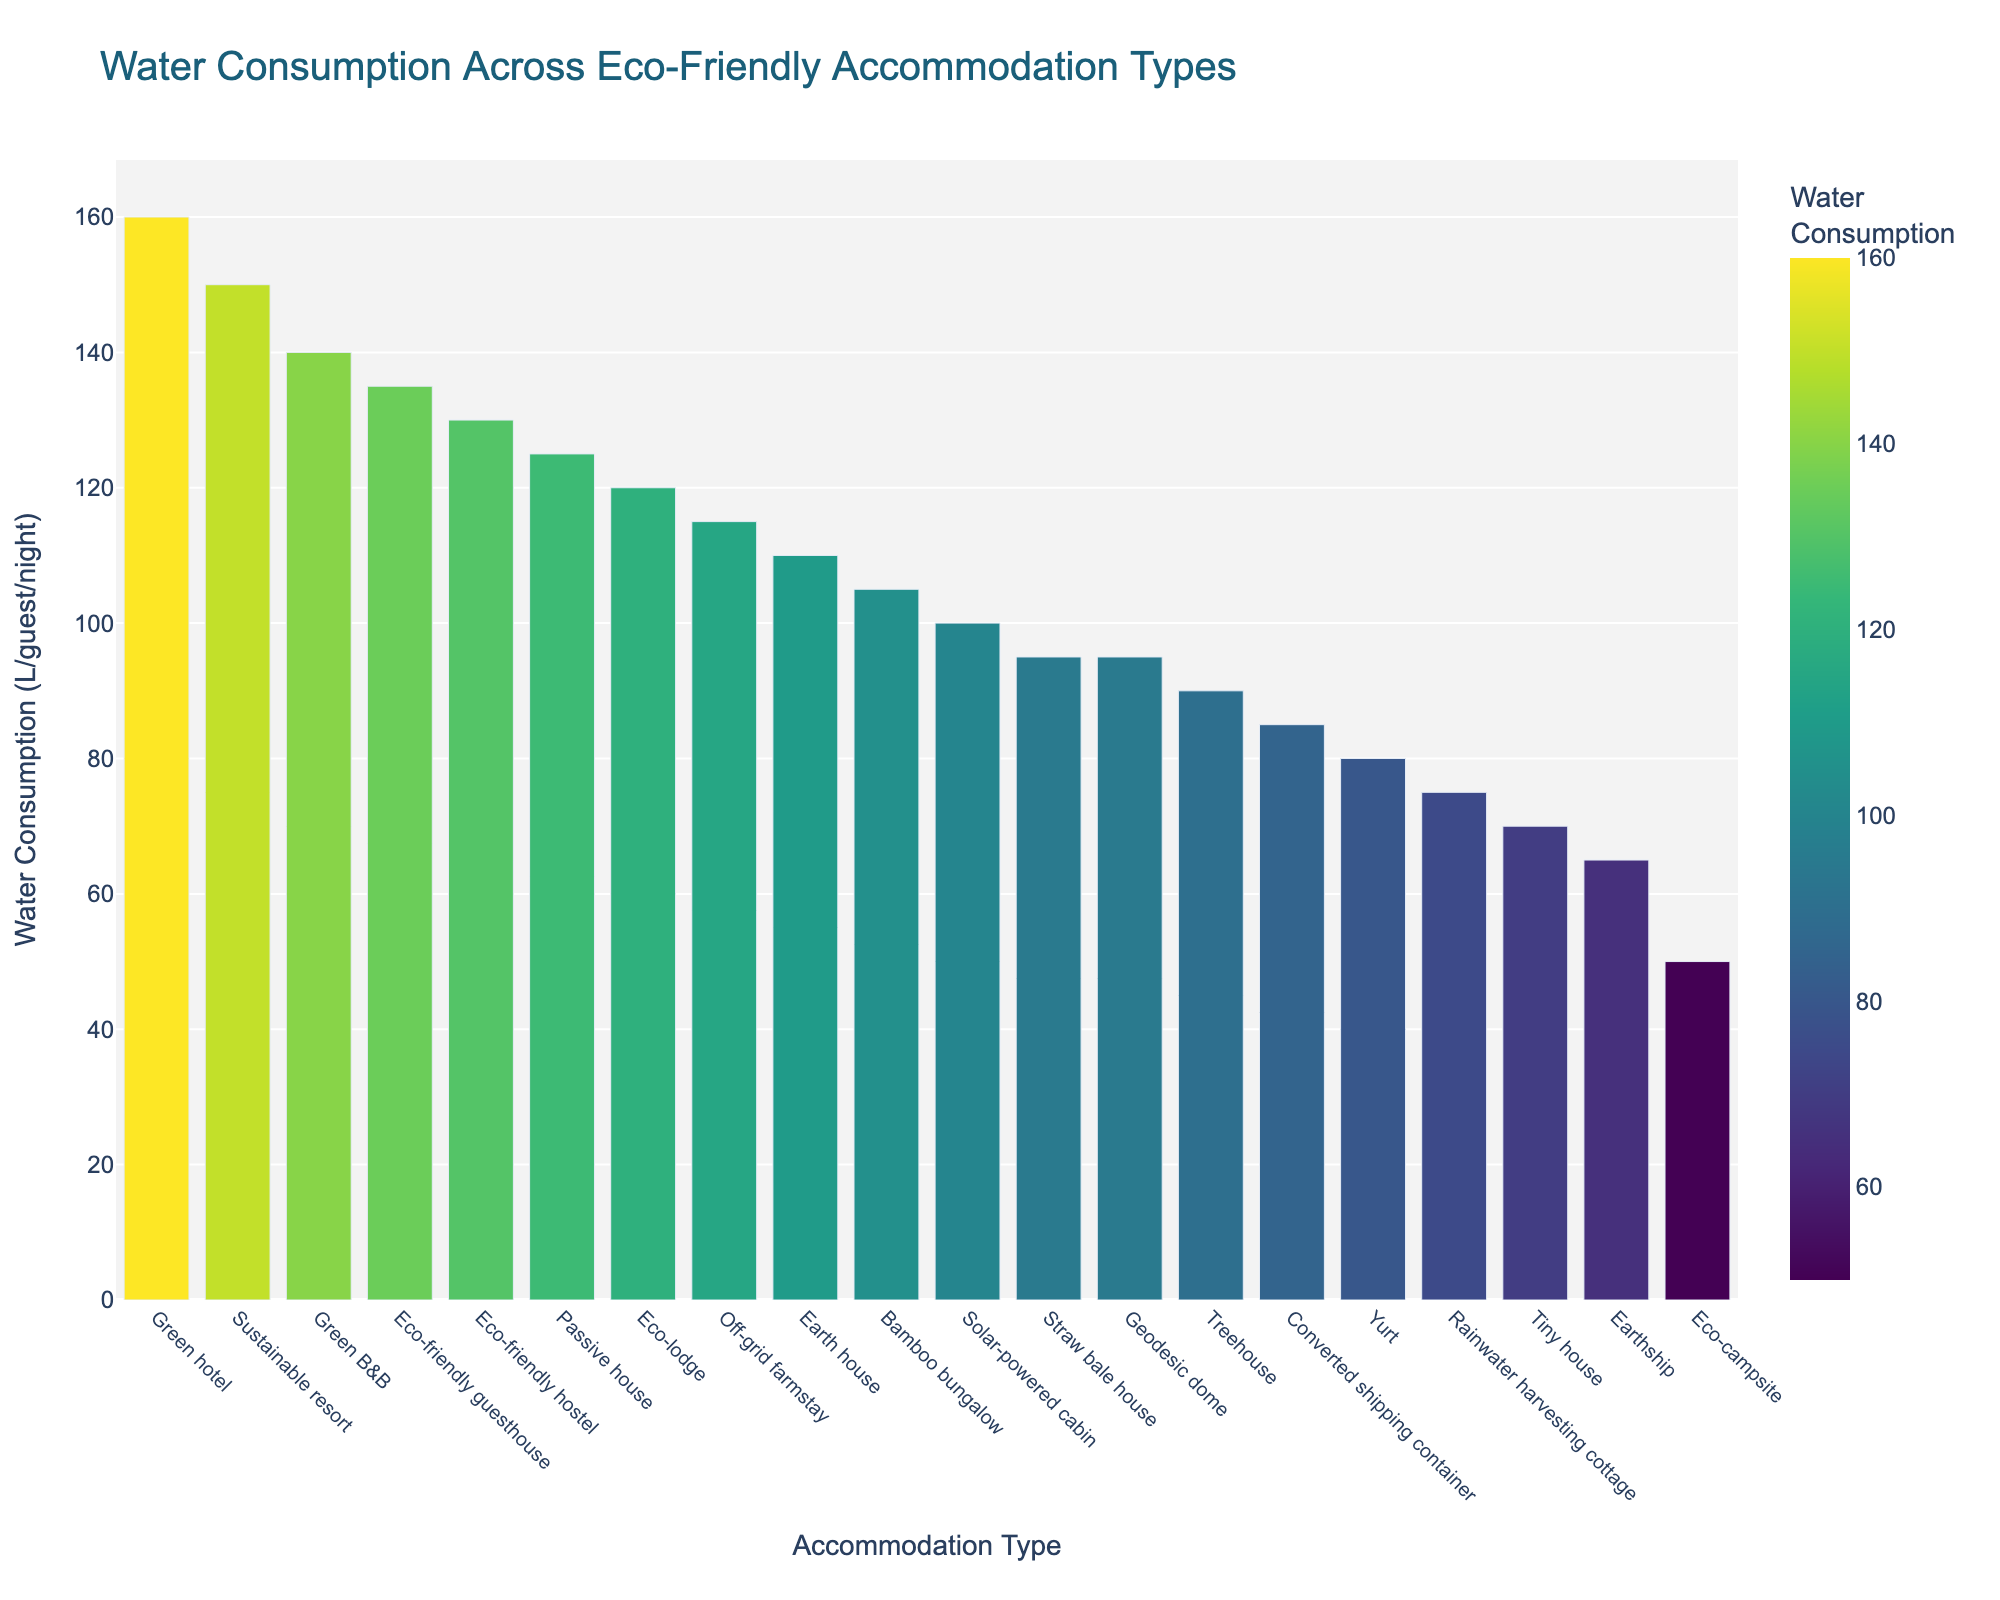Which accommodation type has the highest water consumption? Look at the bar chart and find the bar with the greatest height. The Green hotel has the highest value of 160 liters per guest per night.
Answer: Green hotel Which accommodation type has the lowest water consumption? Look at the bar chart and locate the bar with the smallest height. The Eco-campsite has the lowest value of 50 liters per guest per night.
Answer: Eco-campsite How much more water does a Green hotel consume compared to an Eco-lodge? Find the heights of the bars for the Green hotel and the Eco-lodge. The Green hotel consumes 160 liters, and the Eco-lodge consumes 120 liters, so the difference is 160 - 120.
Answer: 40 liters What is the average water consumption of the Treehouse and Yurt accommodation types? Find the heights of the bars for the Treehouse and Yurt, which are 90 and 80 liters, respectively. The average is (90 + 80) / 2.
Answer: 85 liters Which accommodation types consume more water than the average water consumption of Tiny house and Earthship combined? Find the heights of the bars for the Tiny house and Earthship, which are 70 and 65 liters, respectively. The average is (70 + 65) / 2 = 67.5 liters. Then, identify all bars higher than 67.5 liters.
Answer: Eco-campsite, Rainwater harvesting cottage, Converted shipping container, Yurt, Treehouse, Straw bale house, Bamboo bungalow, Solar-powered cabin, Earth house, Eco-lodge, Off-grid farmstay, Passive house, Eco-friendly hostel, Eco-friendly guesthouse, Green B&B, Sustainable resort, Green hotel By how many liters does the water consumption of the Eco-friendly guesthouse exceed that of the Sustainable resort? Find the heights of the bars for the Eco-friendly guesthouse and Sustainable resort, which are 135 and 150 liters, respectively. The difference is 150 - 135.
Answer: 15 liters What is the median value of water consumption across all accommodation types? List all consumption values: 50, 65, 70, 75, 80, 85, 90, 95, 95, 100, 105, 110, 115, 120, 125, 130, 135, 140, 150, 160. The median value is the middle value in this ordered list, so between the 10th and 11th values. (95 + 100) / 2.
Answer: 97.5 liters Which accommodation type has water consumption exactly between that of Bamboo bungalow and Rainwater harvesting cottage? Find the heights of the bars for the Bamboo bungalow and Rainwater harvesting cottage, which are 105 and 75 liters, respectively. The halfway point is (105 + 75) / 2 = 90 liters. The Treehouse has a consumption of 90 liters.
Answer: Treehouse 